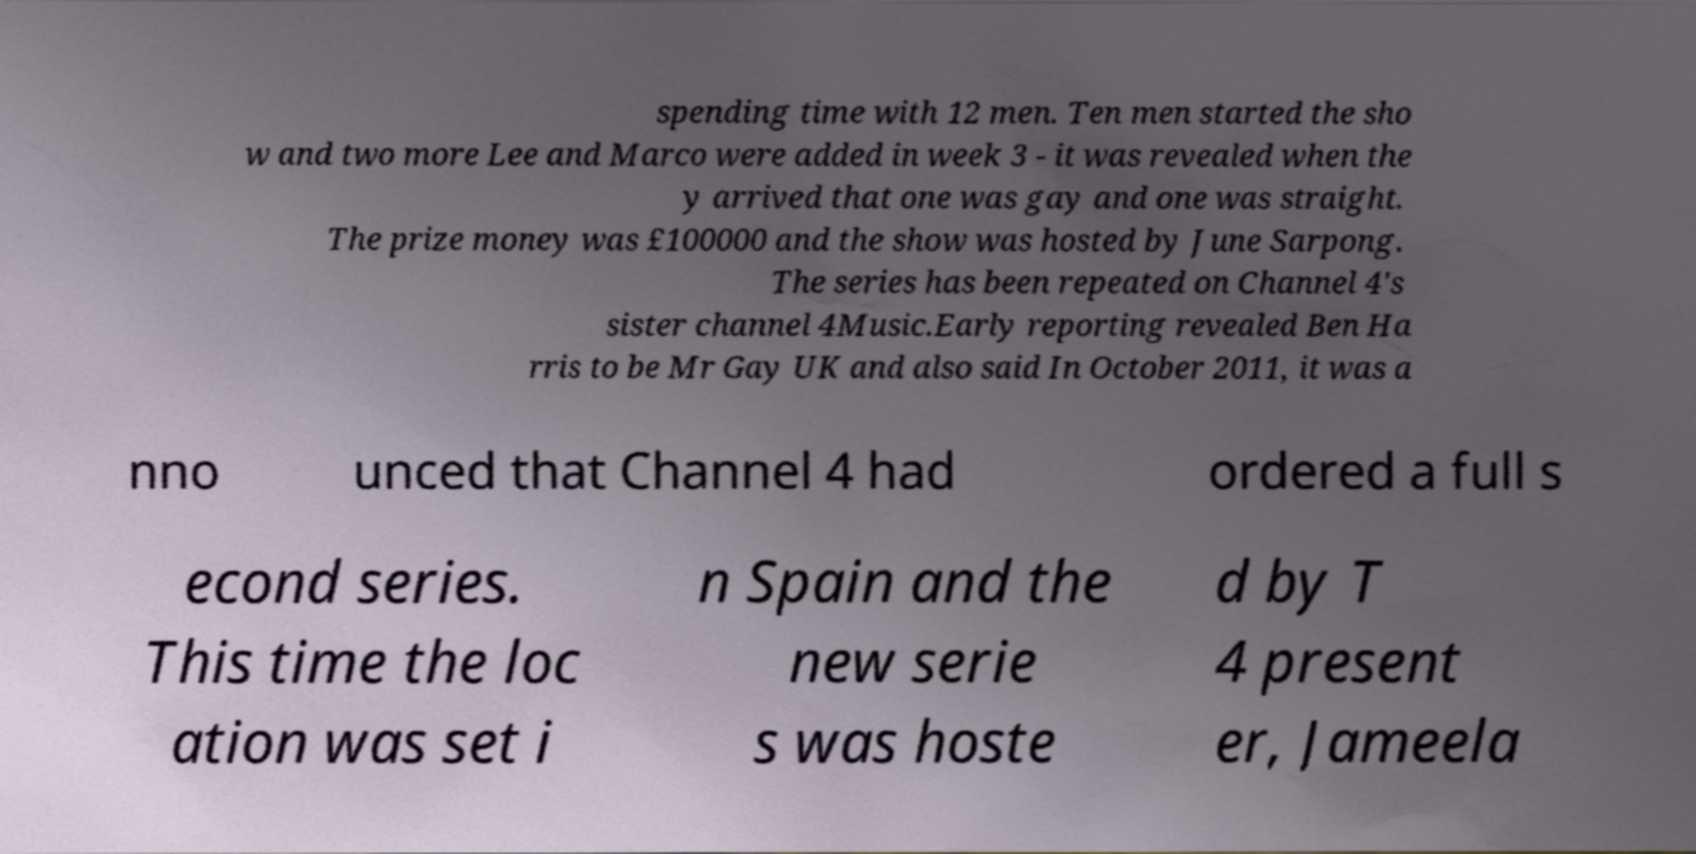Please read and relay the text visible in this image. What does it say? spending time with 12 men. Ten men started the sho w and two more Lee and Marco were added in week 3 - it was revealed when the y arrived that one was gay and one was straight. The prize money was £100000 and the show was hosted by June Sarpong. The series has been repeated on Channel 4's sister channel 4Music.Early reporting revealed Ben Ha rris to be Mr Gay UK and also said In October 2011, it was a nno unced that Channel 4 had ordered a full s econd series. This time the loc ation was set i n Spain and the new serie s was hoste d by T 4 present er, Jameela 